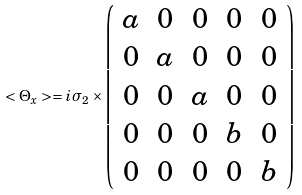<formula> <loc_0><loc_0><loc_500><loc_500>< \Theta _ { x } > = i \sigma _ { 2 } \times \left ( \begin{array} { c c c c c } a & 0 & 0 & 0 & 0 \\ 0 & a & 0 & 0 & 0 \\ 0 & 0 & a & 0 & 0 \\ 0 & 0 & 0 & b & 0 \\ 0 & 0 & 0 & 0 & b \\ \end{array} \right )</formula> 